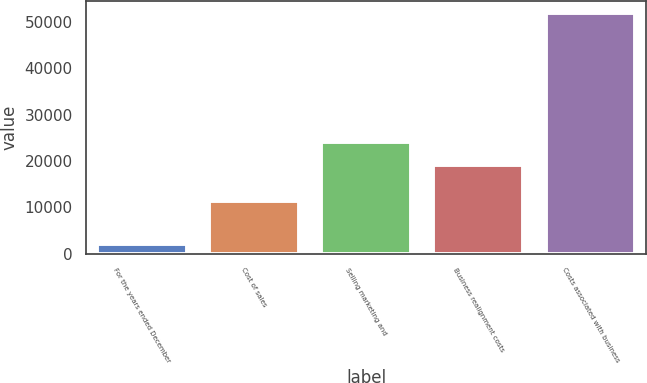<chart> <loc_0><loc_0><loc_500><loc_500><bar_chart><fcel>For the years ended December<fcel>Cost of sales<fcel>Selling marketing and<fcel>Business realignment costs<fcel>Costs associated with business<nl><fcel>2018<fcel>11323<fcel>24083.9<fcel>19103<fcel>51827<nl></chart> 